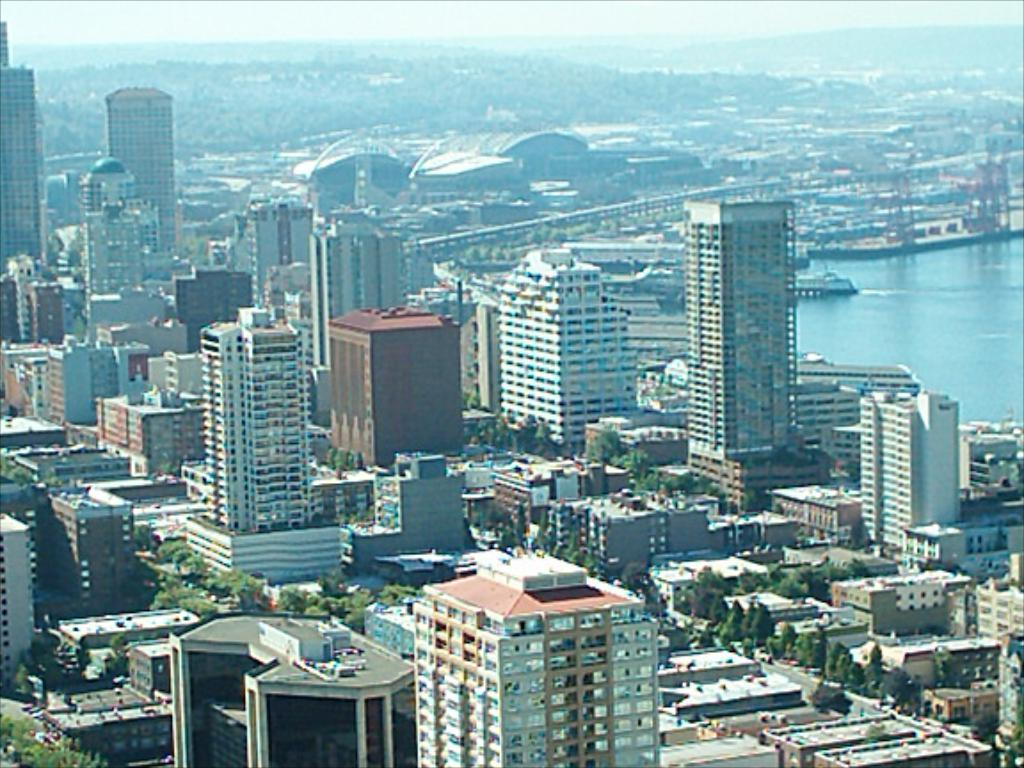What type of structures can be seen in the image? There are buildings in the image. What other natural elements are present in the image? There are trees and water visible in the image. What can be seen in the background of the image? The sky is visible in the background of the image. What type of sticks can be seen in the image? There are no sticks present in the image. What is the topic of the argument taking place in the image? There is no argument present in the image. 